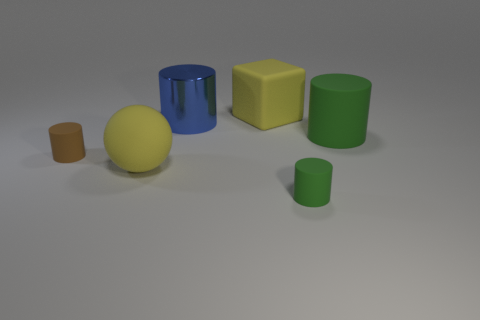How many balls are the same color as the block?
Offer a very short reply. 1. What number of cylinders are brown objects or large green things?
Offer a terse response. 2. What color is the ball that is the same size as the yellow rubber cube?
Provide a short and direct response. Yellow. Are there any large yellow things that are on the left side of the blue cylinder that is right of the matte cylinder that is left of the tiny green rubber cylinder?
Offer a terse response. Yes. What size is the brown cylinder?
Your response must be concise. Small. What number of things are big cyan cubes or big yellow cubes?
Offer a very short reply. 1. There is a block that is the same material as the large green cylinder; what color is it?
Your response must be concise. Yellow. Is the shape of the big blue metallic object on the right side of the tiny brown rubber cylinder the same as  the big green matte thing?
Ensure brevity in your answer.  Yes. How many things are either big yellow rubber things to the left of the block or yellow rubber objects that are on the left side of the big blue metal thing?
Ensure brevity in your answer.  1. There is a big metallic thing that is the same shape as the brown matte object; what is its color?
Your response must be concise. Blue. 